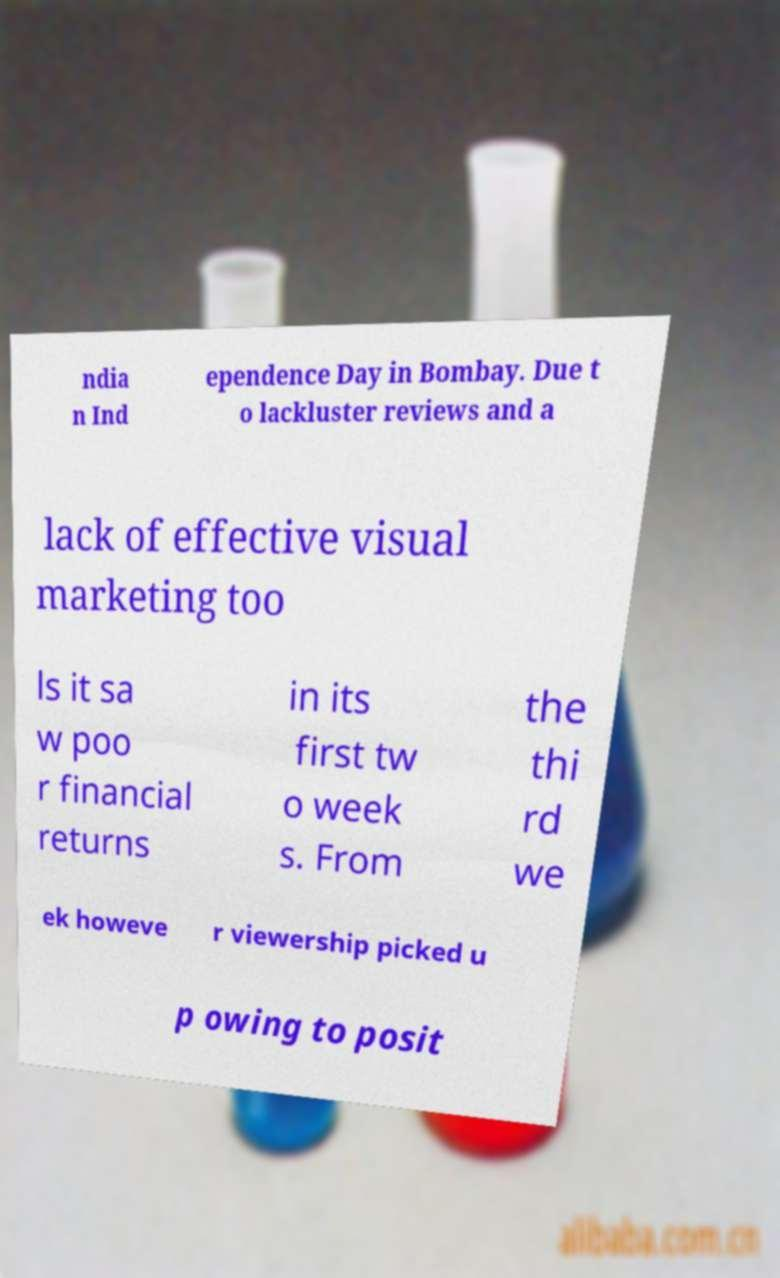Could you assist in decoding the text presented in this image and type it out clearly? ndia n Ind ependence Day in Bombay. Due t o lackluster reviews and a lack of effective visual marketing too ls it sa w poo r financial returns in its first tw o week s. From the thi rd we ek howeve r viewership picked u p owing to posit 